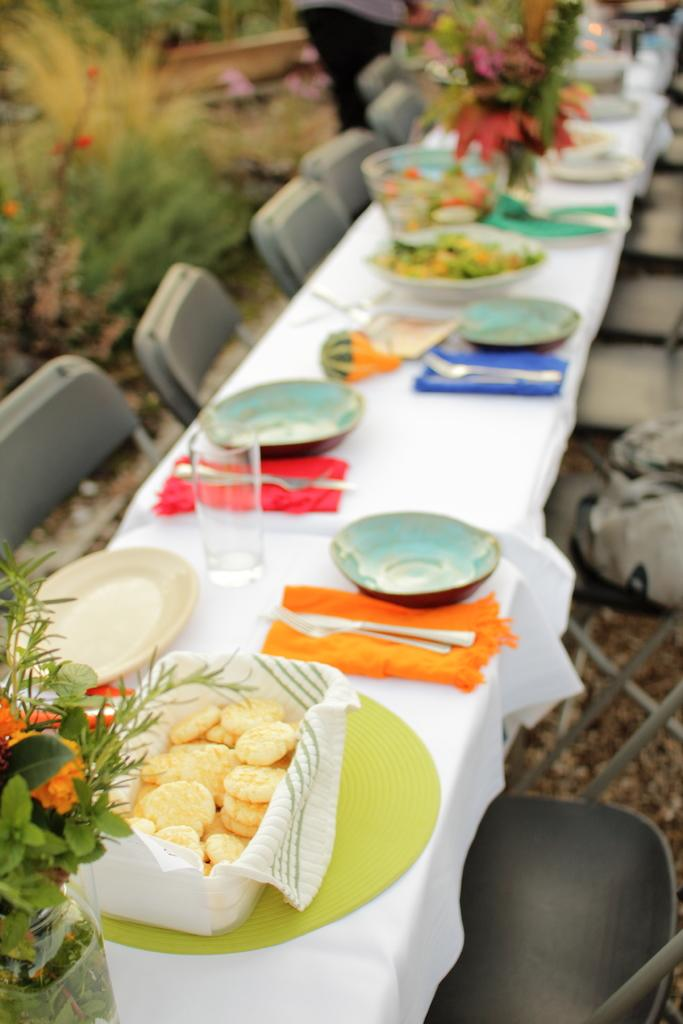What piece of furniture is present in the image? There is a table in the image. What items can be seen on the table? There are bowls, glasses, a flower vase, and spoons on the table. What type of seating is visible in the image? There are chairs in the image. Is there any greenery present in the image? Yes, there is a plant in the image. How many pairs of shoes are visible in the image? There are no shoes present in the image. What type of dolls can be seen interacting with the plant in the image? There are no dolls present in the image. 